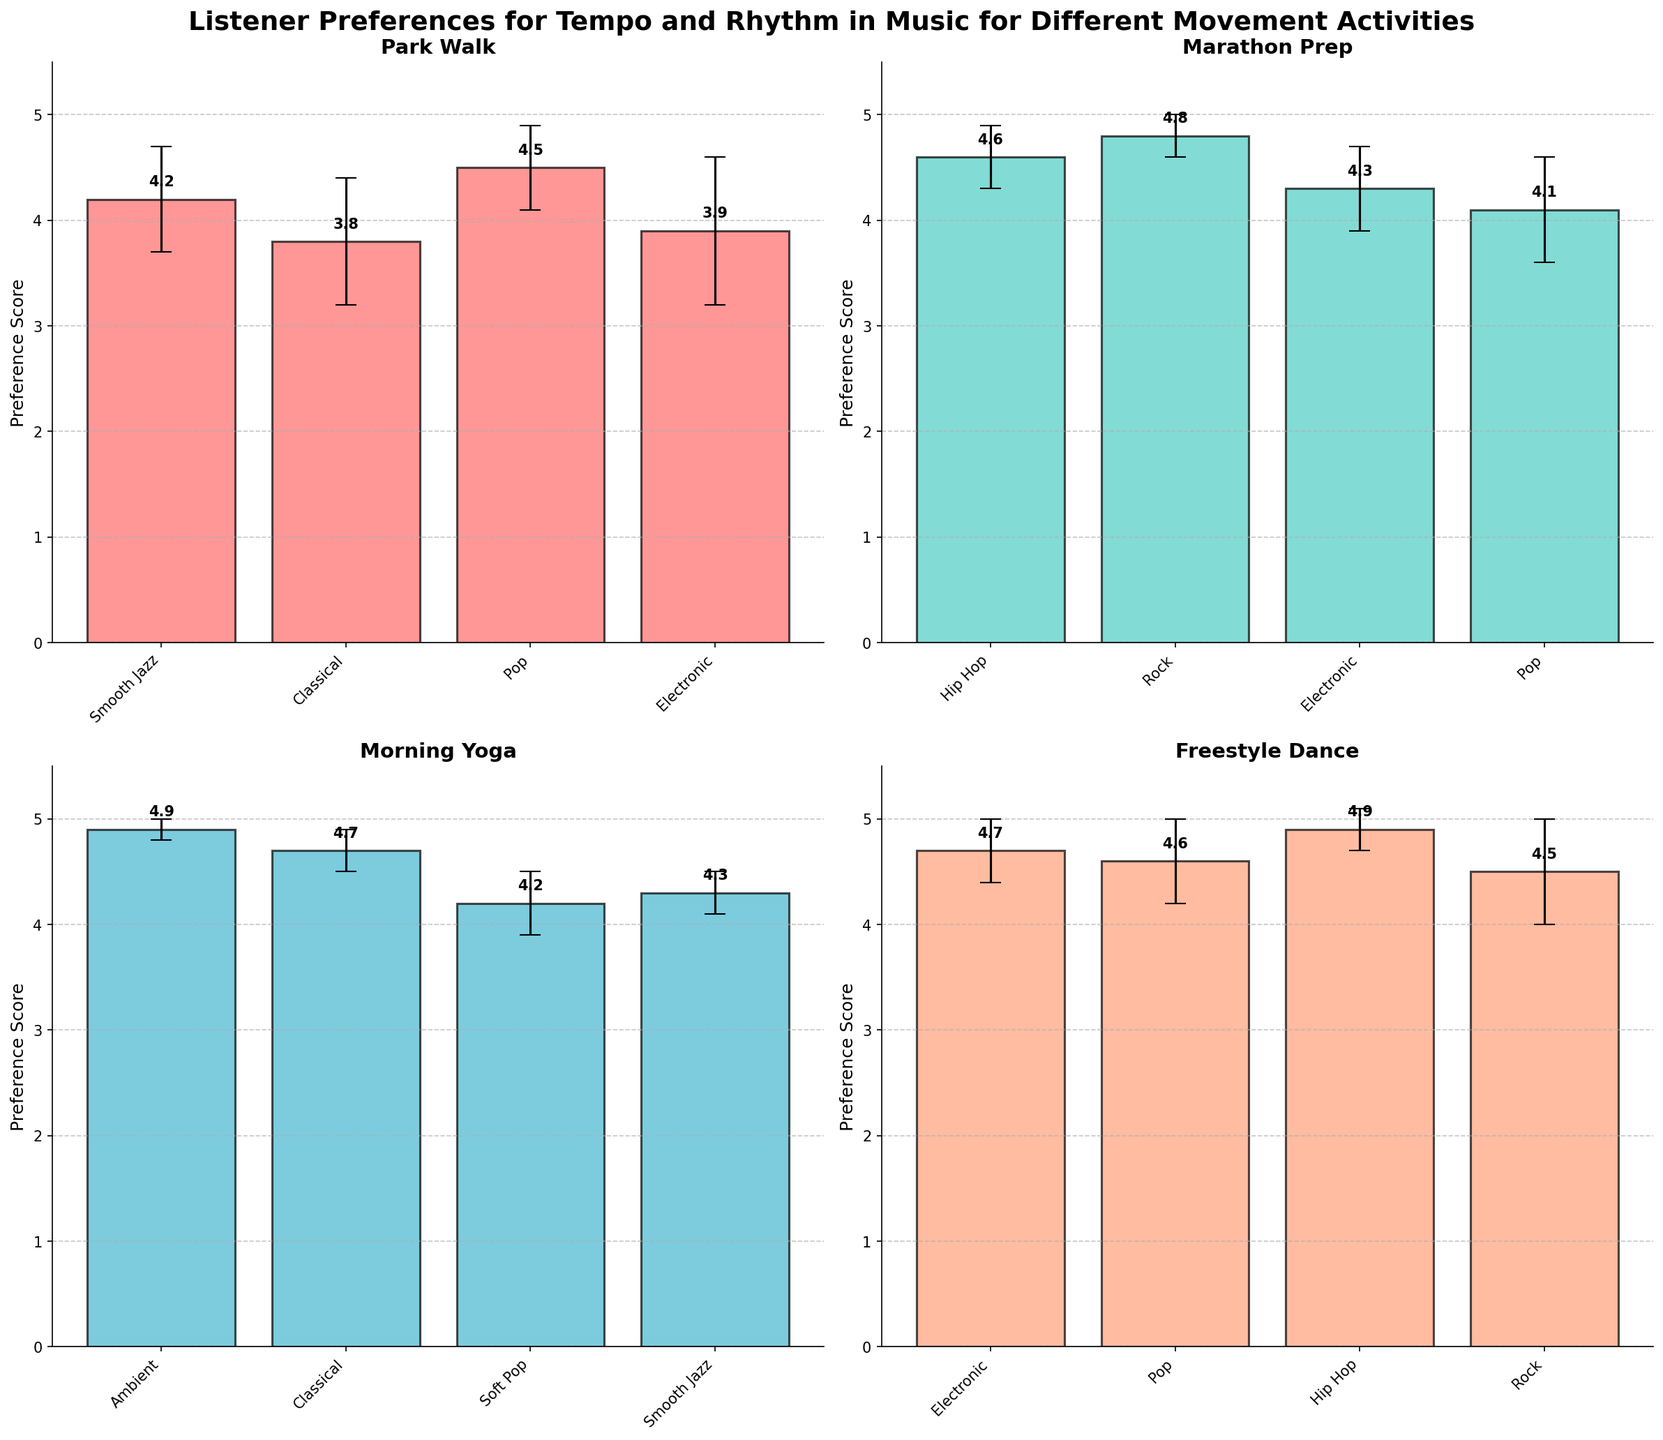What's the title of the figure? The title is displayed prominently at the top of the plot. Each plot usually has a main title summarizing its content.
Answer: Listener Preferences for Tempo and Rhythm in Music for Different Movement Activities In the 'Park Walk' subplot, which music tempo has the highest preference score? Look at the 'Park Walk' subplot. Identify the bar with the highest value, which corresponds to its music tempo.
Answer: Pop What is the difference in preference scores between Hip Hop and Pop for 'Marathon Prep'? Go to the 'Marathon Prep' subplot. Find the bars for Hip Hop and Pop, then subtract the preference score of Pop from Hip Hop (4.6 - 4.1).
Answer: 0.5 Which activity has the least variation in listener preferences as indicated by error bars? Check the error bars across all subplots. The activity with the smallest error bars (smallest standard deviation) indicates the least variation.
Answer: Morning Yoga Between 'Smooth Jazz' and 'Electronic', which one has a lower preference score for 'Freestyle Dance'? In the 'Freestyle Dance' subplot, compare the heights of the bars for 'Smooth Jazz' and 'Electronic'. The lower bar indicates the lower preference score.
Answer: Electronic In the 'Morning Yoga' subplot, which tempo has the highest standard deviation? Evaluate the error bars in the 'Morning Yoga' subplot. The tempo with the largest error bar has the highest standard deviation.
Answer: Soft Pop Combining both preference score and standard deviation, which tempo is relatively more preferred and stable for 'Freestyle Dance'? Look at the 'Freestyle Dance' subplot. Identify the bars with both high preference scores and small error bars (standard deviations).
Answer: Hip Hop For 'Park Walk', calculate the average of the preference scores across all music tempos. Sum the preference scores for all tempos in 'Park Walk' and divide by the number of tempos: (4.2 + 3.8 + 4.5 + 3.9) / 4.
Answer: 4.1 Which activity has the highest overall preference score? Compare the highest bars across all subplots. The tallest bar represents the highest overall preference score.
Answer: Freestyle Dance In the 'Marathon Prep' subplot, are there any music tempos with equal preference scores? Examine the height of the bars in the 'Marathon Prep' subplot and see if any bars reach the same height.
Answer: No 